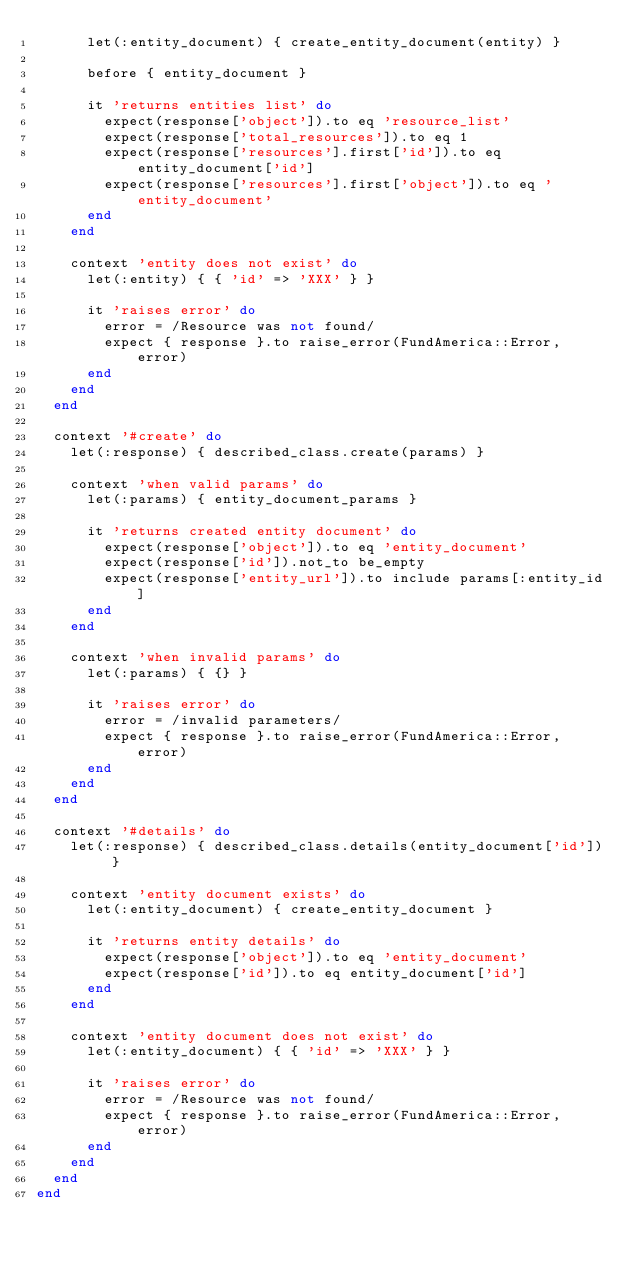<code> <loc_0><loc_0><loc_500><loc_500><_Ruby_>      let(:entity_document) { create_entity_document(entity) }

      before { entity_document }

      it 'returns entities list' do
        expect(response['object']).to eq 'resource_list'
        expect(response['total_resources']).to eq 1
        expect(response['resources'].first['id']).to eq entity_document['id']
        expect(response['resources'].first['object']).to eq 'entity_document'
      end
    end

    context 'entity does not exist' do
      let(:entity) { { 'id' => 'XXX' } }

      it 'raises error' do
        error = /Resource was not found/
        expect { response }.to raise_error(FundAmerica::Error, error)
      end
    end
  end

  context '#create' do
    let(:response) { described_class.create(params) }

    context 'when valid params' do
      let(:params) { entity_document_params }

      it 'returns created entity document' do
        expect(response['object']).to eq 'entity_document'
        expect(response['id']).not_to be_empty
        expect(response['entity_url']).to include params[:entity_id]
      end
    end

    context 'when invalid params' do
      let(:params) { {} }

      it 'raises error' do
        error = /invalid parameters/
        expect { response }.to raise_error(FundAmerica::Error, error)
      end
    end
  end

  context '#details' do
    let(:response) { described_class.details(entity_document['id']) }

    context 'entity document exists' do
      let(:entity_document) { create_entity_document }

      it 'returns entity details' do
        expect(response['object']).to eq 'entity_document'
        expect(response['id']).to eq entity_document['id']
      end
    end

    context 'entity document does not exist' do
      let(:entity_document) { { 'id' => 'XXX' } }

      it 'raises error' do
        error = /Resource was not found/
        expect { response }.to raise_error(FundAmerica::Error, error)
      end
    end
  end
end
</code> 